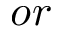<formula> <loc_0><loc_0><loc_500><loc_500>o r</formula> 